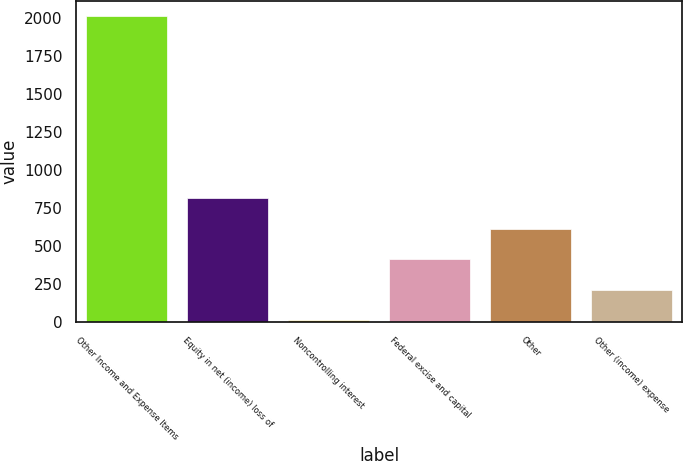Convert chart to OTSL. <chart><loc_0><loc_0><loc_500><loc_500><bar_chart><fcel>Other Income and Expense Items<fcel>Equity in net (income) loss of<fcel>Noncontrolling interest<fcel>Federal excise and capital<fcel>Other<fcel>Other (income) expense<nl><fcel>2010<fcel>812.4<fcel>14<fcel>413.2<fcel>612.8<fcel>213.6<nl></chart> 